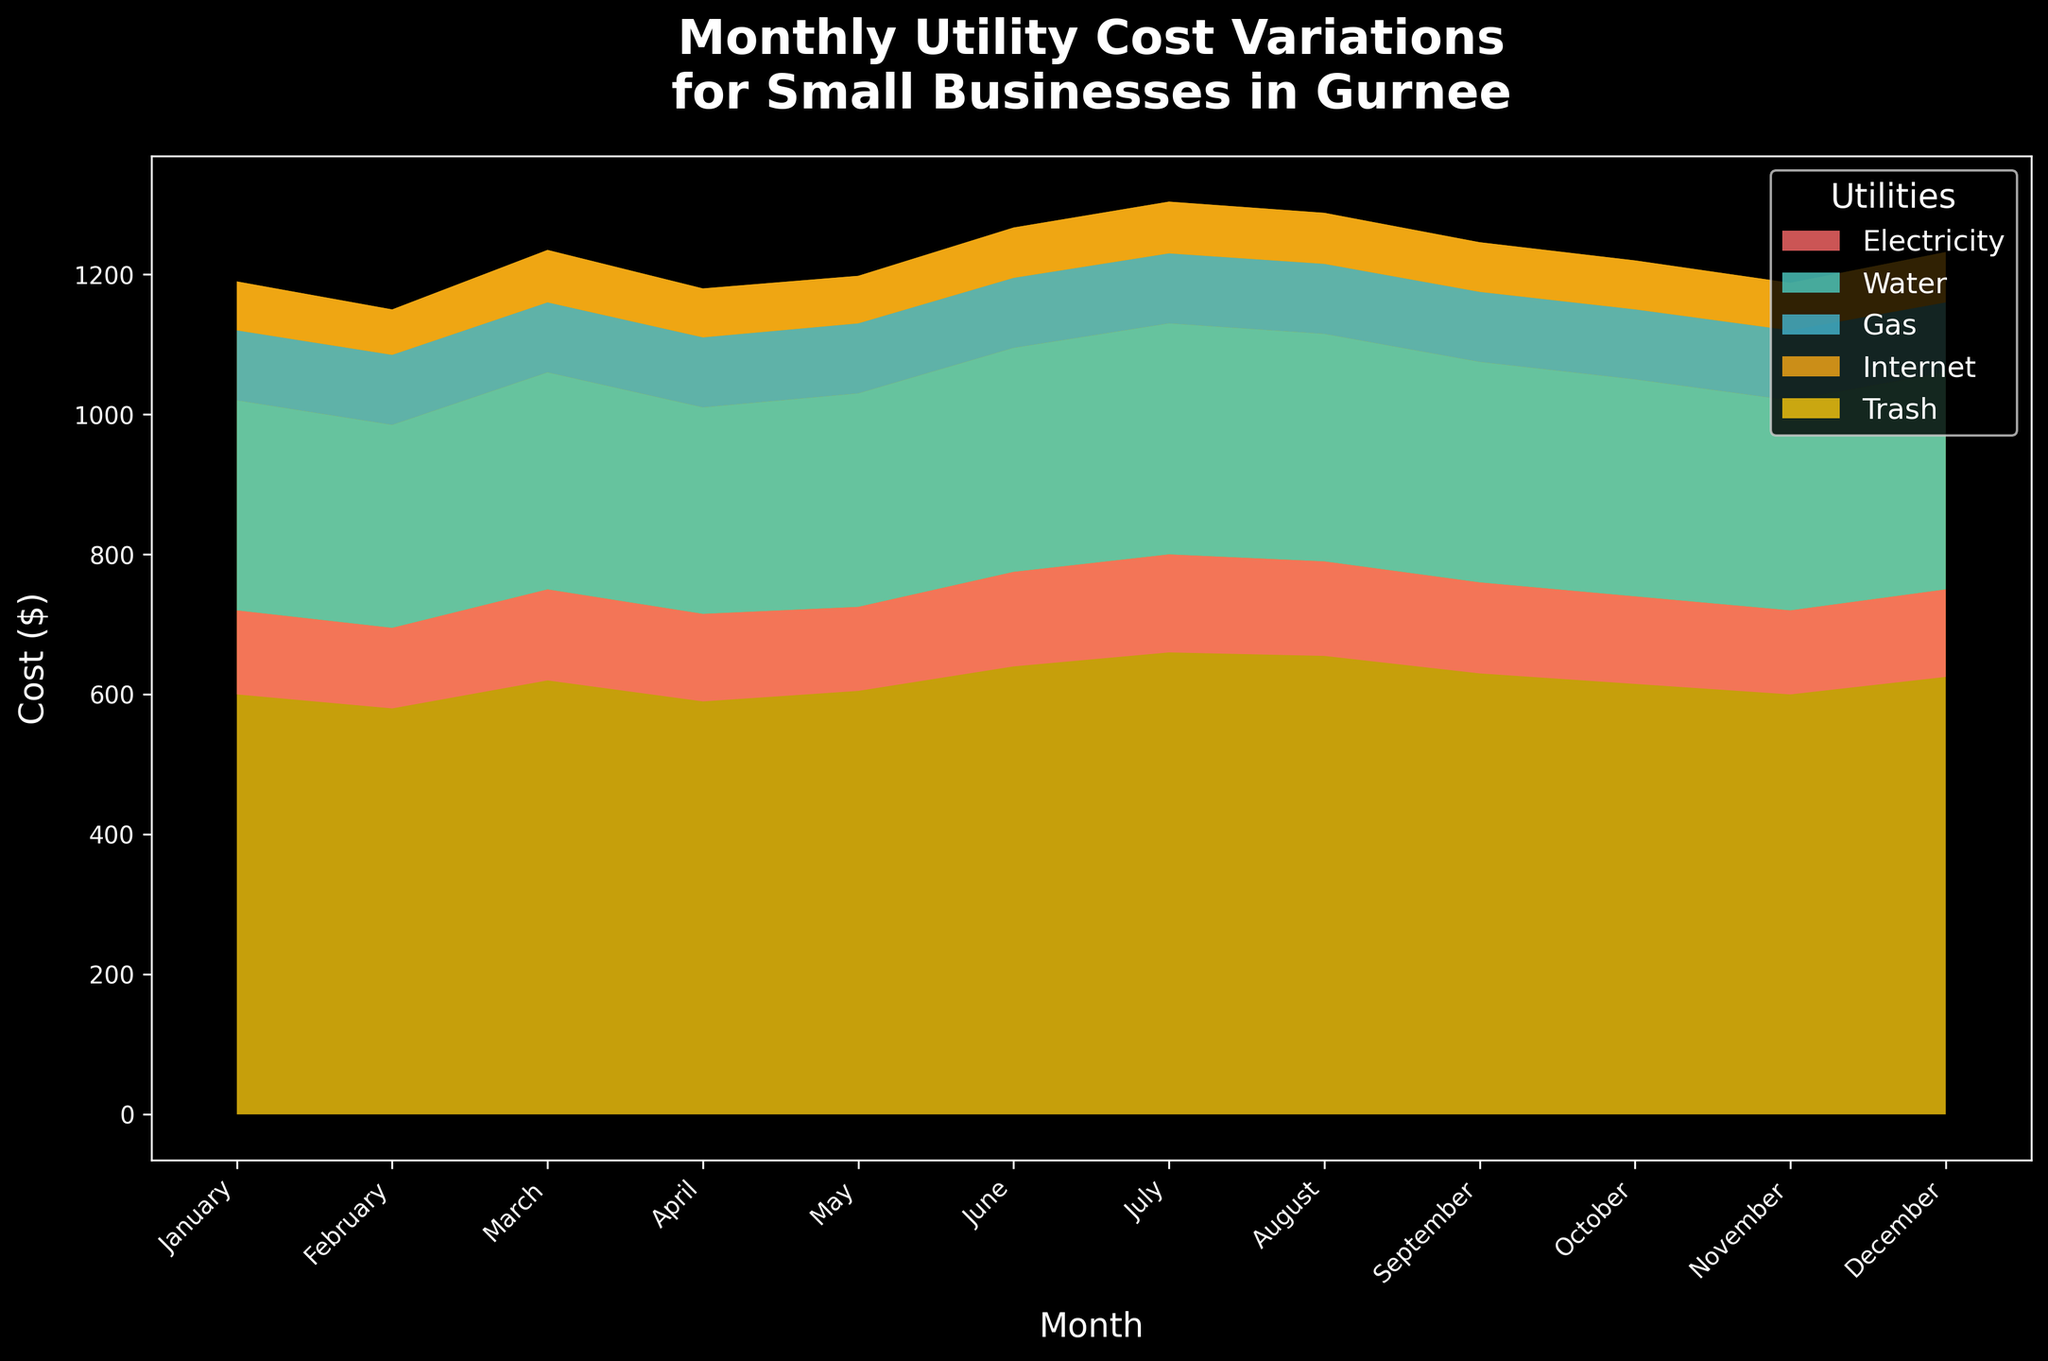What is the title of the figure? The title of the figure is located at the top of the plot. It usually summarizes the main topic or information presented.
Answer: Monthly Utility Cost Variations for Small Businesses in Gurnee Which utility cost is represented by the light blue color? By referring to the legend on the figure, each color represents a different utility cost. The light blue color corresponds to Water.
Answer: Water How much was the monthly cost for Gas in July? Locate the area for July on the x-axis and check the height of the Gas stream (represented in red).
Answer: $330 Which month had the highest total utility cost? To determine the highest total cost, look for the month with the tallest combined stream heights on the y-axis. July appears to have the highest combined utility costs.
Answer: July What is the average monthly cost of Electricity over the year? Calculate the average by summing the monthly Electricity costs and dividing by 12: (600 + 580 + 620 + 590 + 605 + 640 + 660 + 655 + 630 + 615 + 600 + 625) / 12.
Answer: $622.08 Which utility had the least fluctuation throughout the year? Compare the stream heights variation for all utilities across months. Internet cost remains constant at $100 each month.
Answer: Internet How does the total utility cost in September compare to August? Compare the combined heights of all streams for August and September. September seems slightly lower than August based on the stream layers.
Answer: September is lower What is the sum of Electricity and Trash cost in March? Add the heights of the Electricity and Trash streams for March: 620 (Electricity) + 75 (Trash).
Answer: $695 Which utility shows an increasing trend from January to July? Look for a stream that consistently increases from January to July. Gas, marked in red, increases from $300 to $330.
Answer: Gas By how much do Electricity costs increase from February to June? Subtract February's Electricity cost from June's: 640 (June) - 580 (February).
Answer: $60 